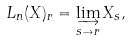<formula> <loc_0><loc_0><loc_500><loc_500>L _ { n } ( X ) _ { r } & = \varinjlim _ { s \to r } X _ { s } ,</formula> 